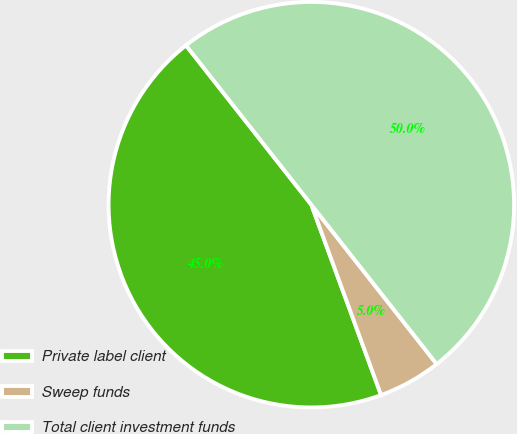<chart> <loc_0><loc_0><loc_500><loc_500><pie_chart><fcel>Private label client<fcel>Sweep funds<fcel>Total client investment funds<nl><fcel>44.98%<fcel>5.02%<fcel>50.0%<nl></chart> 